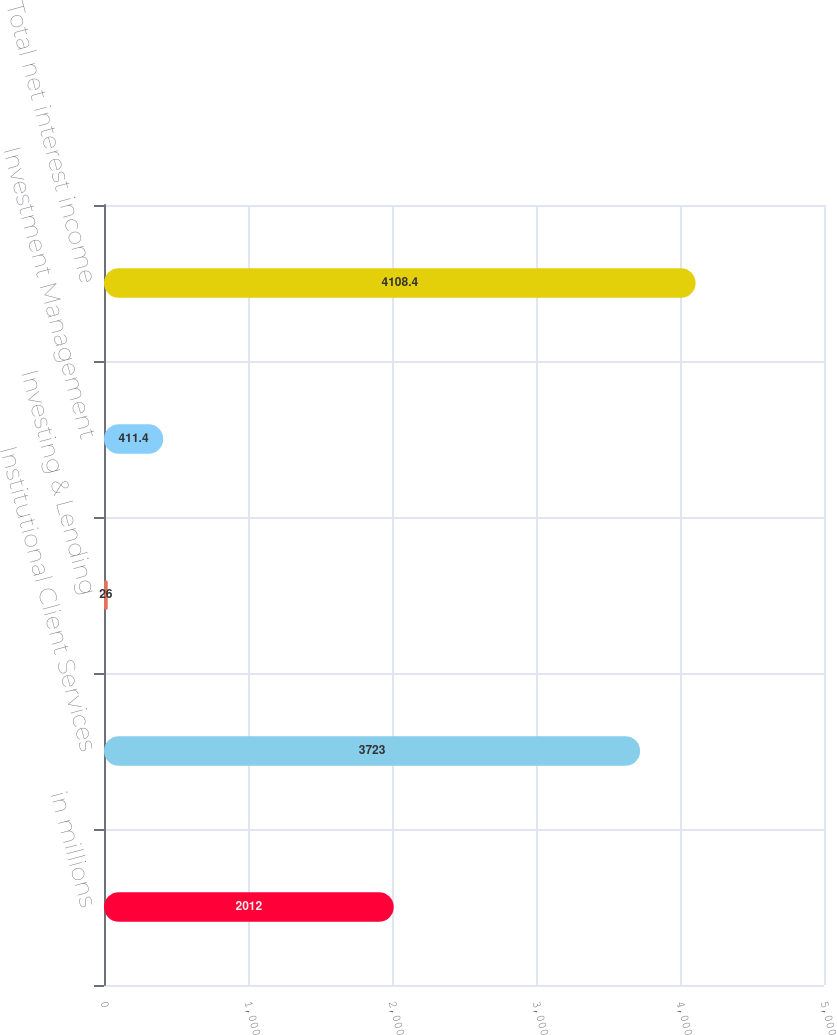<chart> <loc_0><loc_0><loc_500><loc_500><bar_chart><fcel>in millions<fcel>Institutional Client Services<fcel>Investing & Lending<fcel>Investment Management<fcel>Total net interest income<nl><fcel>2012<fcel>3723<fcel>26<fcel>411.4<fcel>4108.4<nl></chart> 